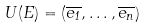Convert formula to latex. <formula><loc_0><loc_0><loc_500><loc_500>U ( E ) = ( \overline { e _ { 1 } } , \dots , \overline { e _ { n } } )</formula> 